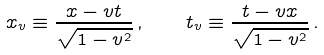<formula> <loc_0><loc_0><loc_500><loc_500>x _ { v } \equiv \frac { x - v t } { \sqrt { 1 - v ^ { 2 } } } \, , \quad t _ { v } \equiv \frac { t - v x } { \sqrt { 1 - v ^ { 2 } } } \, .</formula> 